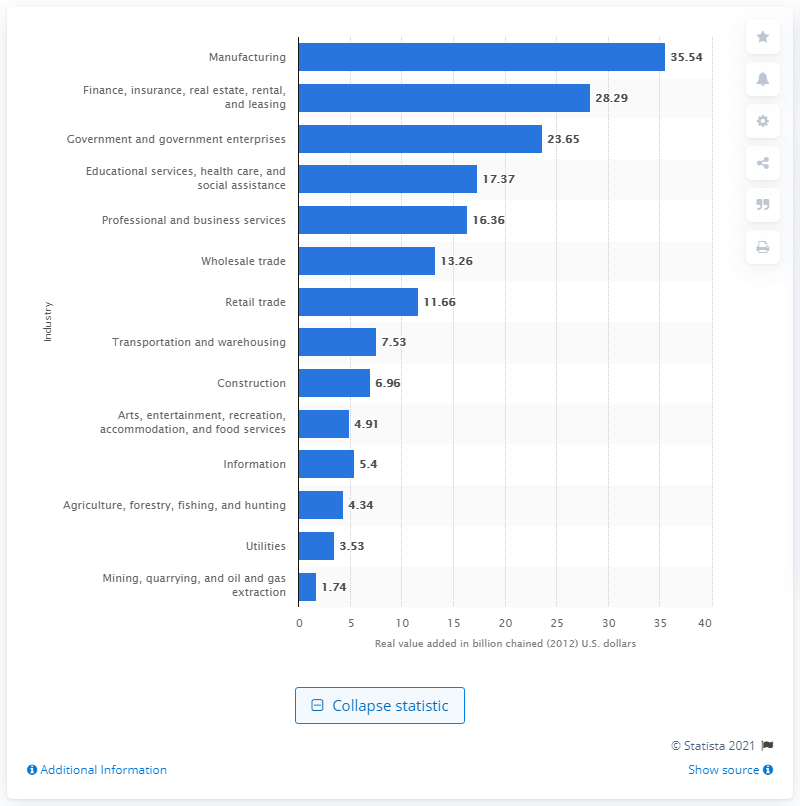From the information provided, can you surmise the overall health of Kentucky's economy? Based on the diverse economic contributions across various industries, with manufacturing leading substantially, followed by a solid performance from finance and government sectors, Kentucky shows a robust mix indicative of a stable economy. Diversification and sizeable contributions from multiple sectors are generally positive signs of economic health. 